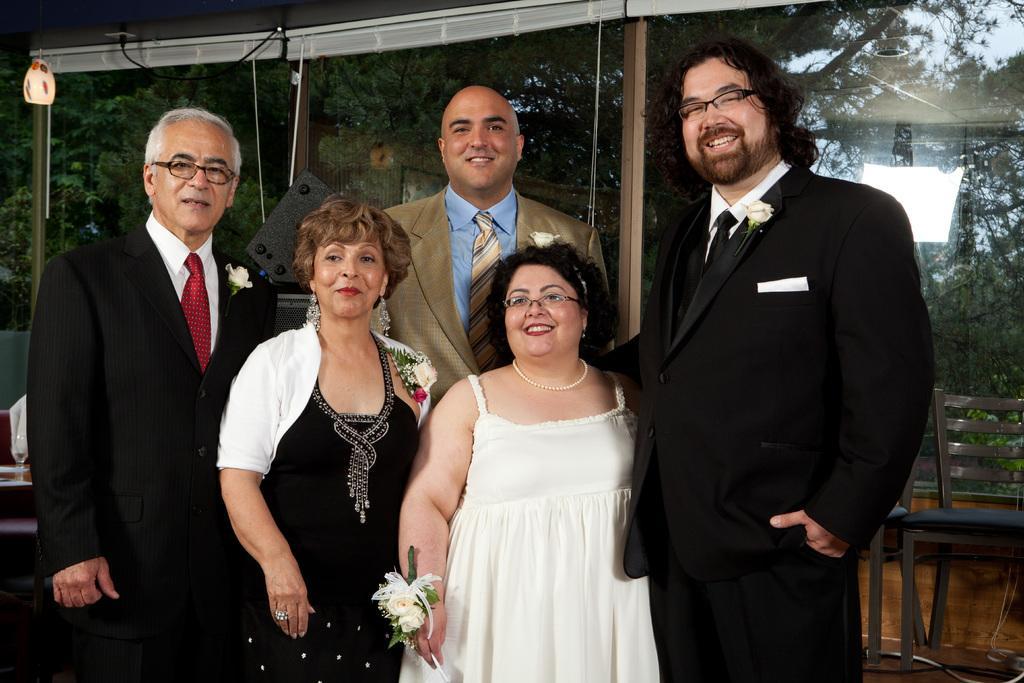Could you give a brief overview of what you see in this image? In this picture there are five people standing. They all are smiling and posing for picture. All are well dressed. Behind them there are chairs and tables. In the background there is window blinds, trees, lamps and glass. 